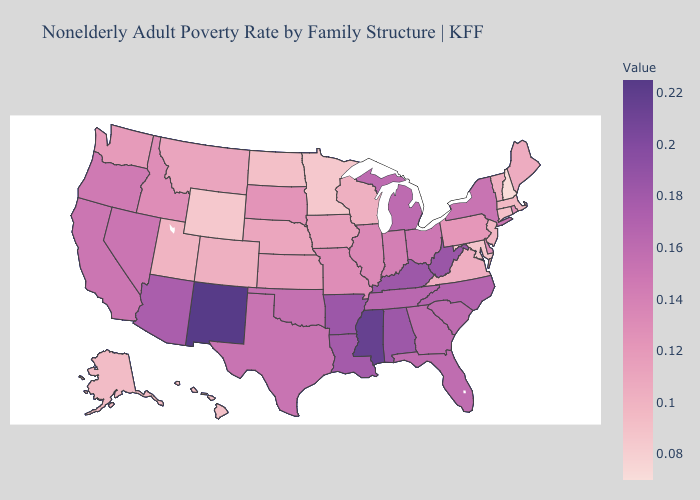Does New Hampshire have the lowest value in the USA?
Be succinct. Yes. Which states have the lowest value in the USA?
Short answer required. New Hampshire. Does New York have the highest value in the Northeast?
Quick response, please. Yes. Among the states that border New York , which have the highest value?
Answer briefly. Pennsylvania. Which states hav the highest value in the Northeast?
Give a very brief answer. New York. Among the states that border Nevada , which have the lowest value?
Write a very short answer. Utah. Does New Mexico have the highest value in the USA?
Keep it brief. Yes. 